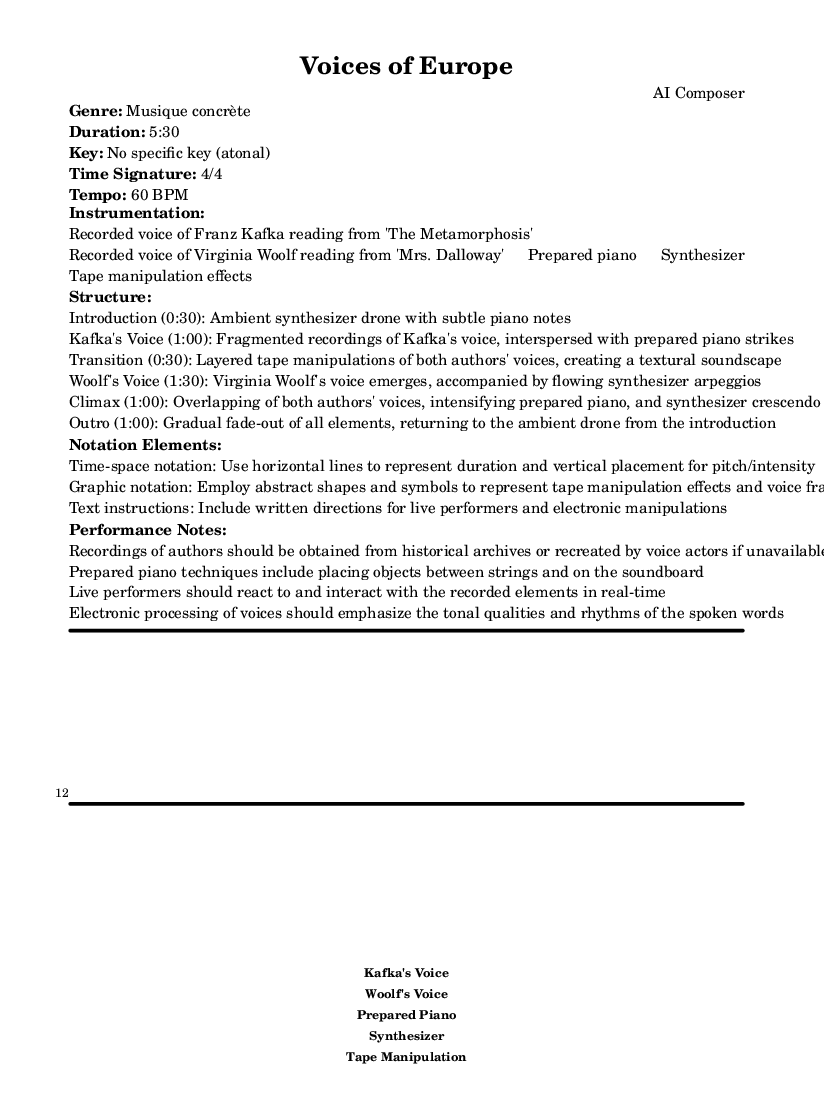What is the time signature of this music? The time signature is indicated to be 4/4, which means there are four beats in a measure and the quarter note gets one beat.
Answer: 4/4 What is the duration of this piece? The total duration of the piece is specified as 5:30, indicating that it lasts for five minutes and thirty seconds.
Answer: 5:30 Which authors’ voices are featured in the composition? The sheet music lists Franz Kafka and Virginia Woolf as the featured authors whose recorded voices are incorporated in the piece.
Answer: Franz Kafka, Virginia Woolf What techniques are suggested for the prepared piano? The performance notes recommend placing objects between the strings and on the soundboard to create unique tonal effects on the prepared piano.
Answer: Placing objects What is the structural role of the transition section? The transition section, lasting for 30 seconds, aims to create a layered soundscape using tape manipulations of both authors' voices, suggesting a shift from one thematic focus to another in the piece.
Answer: Layered tape manipulations What notation elements are described in the sheet music? The notation elements include time-space notation, graphic notation, and text instructions, which guide how the music should be interpreted and performed.
Answer: Time-space notation, graphic notation, text instructions What is the climax duration in this piece? The climax section of the composition is indicated to last for 1:00, representing a significant peak in intensity and overlapping elements.
Answer: 1:00 